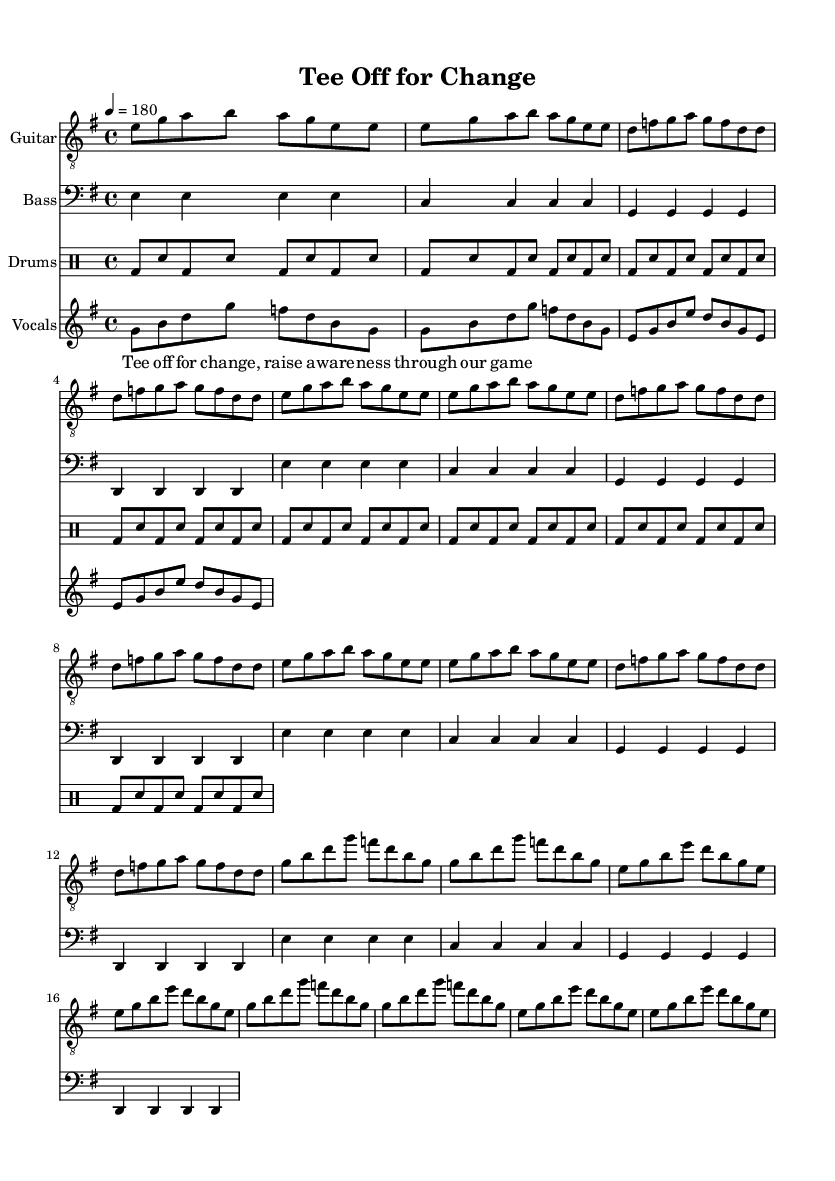What is the key signature of this music? The key signature is E minor, which contains one sharp (F#) and is indicated right after the clef sign at the beginning of the staff.
Answer: E minor What is the time signature of this music? The time signature is 4/4, which is shown at the beginning of the score. This means there are four beats in each measure and a quarter note receives one beat.
Answer: 4/4 What is the tempo marking of this music? The tempo marking is 180 beats per minute, indicated above the staff. This suggests a fast-paced feel typical of punk music.
Answer: 180 How many times does the chorus repeat? The chorus is repeated 2 times as indicated by the "repeat unfold" directive before the chorus section, signaling performers to play it twice.
Answer: 2 What style does this piece represent? This piece represents punk style, which is characterized by its fast tempo, straightforward chords, and socially conscious lyrics, as seen in both the rhythm and lyrical content.
Answer: Punk What instruments are included in this score? The score includes Guitar, Bass, Drums, and Vocals, as specified at the beginning of each staff within the score. This combination is typical for punk music.
Answer: Guitar, Bass, Drums, Vocals 